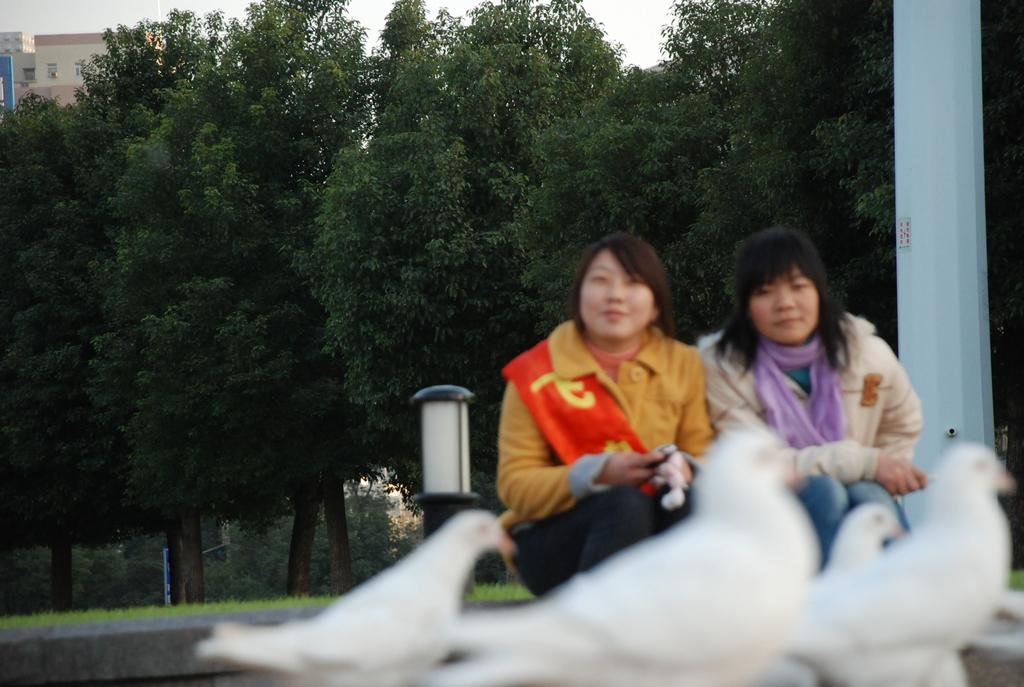What animals are in the foreground of the image? There are pigeons in the foreground of the image. What are the two ladies in the image doing? The two ladies are sitting in the image. What can be seen in the background of the image? There are trees and a building in the background of the image. What is the purpose of the light pole in the image? The light pole is likely for providing illumination in the area. What type of ink is being used by the pigeons in the image? There is no ink present in the image, as it features pigeons in the foreground. How many times do the ladies sneeze in the image? There is no indication of sneezing in the image, as it shows two ladies sitting. 